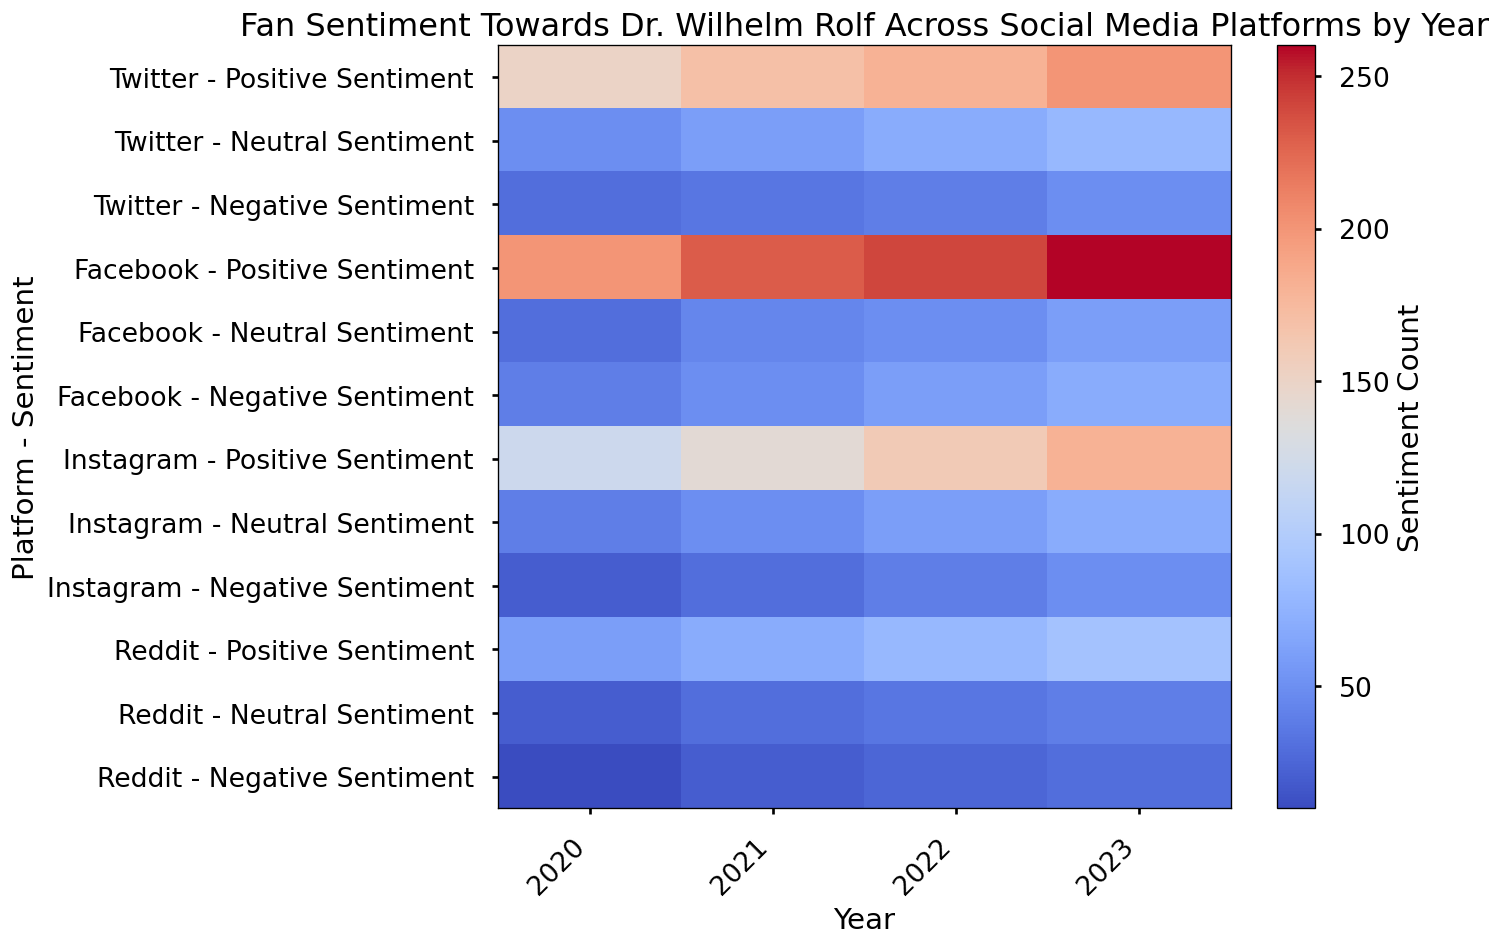What's the general trend in positive sentiment on Twitter over the years? To determine the trend, observe the "Twitter - Positive Sentiment" values across each row from 2020 to 2023. Positive sentiment increases from 150 in 2020 to 170 in 2021, 180 in 2022, and 200 in 2023.
Answer: Increasing Which platform had the highest negative sentiment in 2023? Look at the "Negative Sentiment" values in 2023. The values are Twitter (50), Facebook (70), Instagram (50), Reddit (30). The highest value is 70 on Facebook.
Answer: Facebook Did Instagram's positive sentiment ever exceed 150 in any year? Check the "Instagram - Positive Sentiment" values for each year: 2020 (120), 2021 (140), 2022 (160), 2023 (180). The values exceed 150 in 2022 and 2023.
Answer: Yes How does the neutral sentiment on Reddit in 2020 compare to 2023? Compare "Reddit - Neutral Sentiment" in 2020 and 2023. The values are 20 in 2020 and 40 in 2023. 2023's value is higher.
Answer: Higher in 2023 Which year had the most significant jump in neutral sentiment for Facebook? Examine "Facebook - Neutral Sentiment" values year by year: 2020 (30), 2021 (45), 2022 (50), 2023 (60). The jump from 2021 to 2022 is 5 and from 2022 to 2023 is 10. The jump from 2020 to 2021 is 15.
Answer: 2021 List the years where negative sentiment on Reddit increased. Check the "Reddit - Negative Sentiment" values for each year: 2020 (10), 2021 (20), 2022 (25), 2023 (30). The negative sentiment increases each year from 2020 to 2023.
Answer: 2021, 2022, 2023 By how much did Twitter's positive sentiment grow from 2020 to 2023? Subtract the 2020 value from the 2023 value in "Twitter - Positive Sentiment": 200 (2023) - 150 (2020) equals 50.
Answer: 50 Between 2021 and 2022, which platform saw the largest increase in positive sentiment? Calculate the difference for positive sentiment between 2021 and 2022 for each platform: Twitter (180-170=10), Facebook (240-230=10), Instagram (160-140=20), Reddit (80-70=10). Instagram saw the largest increase (20).
Answer: Instagram Does Facebook show a consistent rise in negative sentiment every year? Check "Facebook - Negative Sentiment" values for: 2020 (40), 2021 (50), 2022 (60), 2023 (70). The values consistently increase every year.
Answer: Yes What's the overall highest recorded neutral sentiment across all platforms and years? Scan all "Neutral Sentiment" values to find the highest: The maximum value is 80 on Twitter in 2023.
Answer: 80 